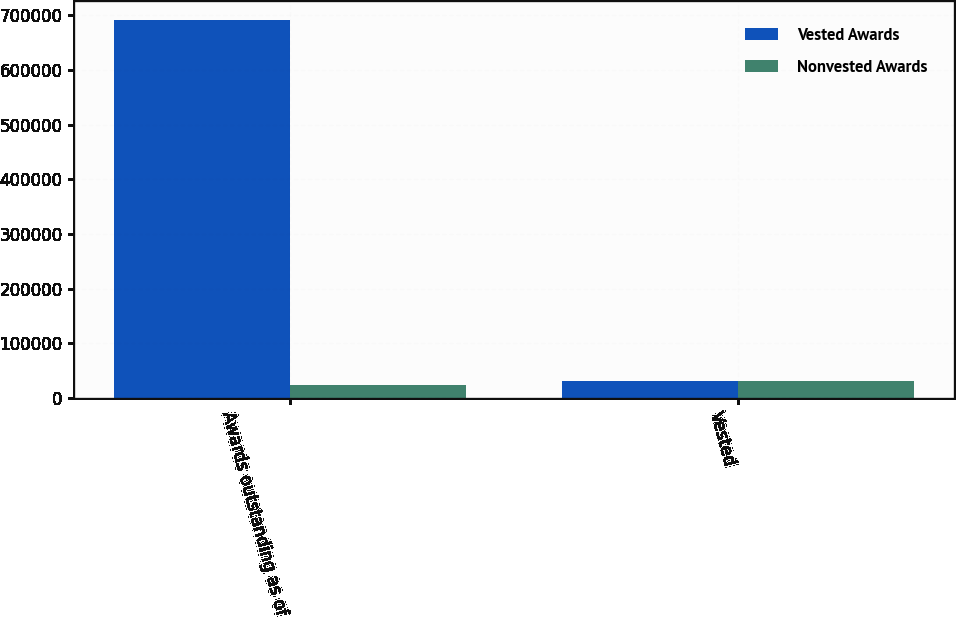Convert chart. <chart><loc_0><loc_0><loc_500><loc_500><stacked_bar_chart><ecel><fcel>Awards outstanding as of<fcel>Vested<nl><fcel>Vested Awards<fcel>691191<fcel>31361<nl><fcel>Nonvested Awards<fcel>24635<fcel>31361<nl></chart> 